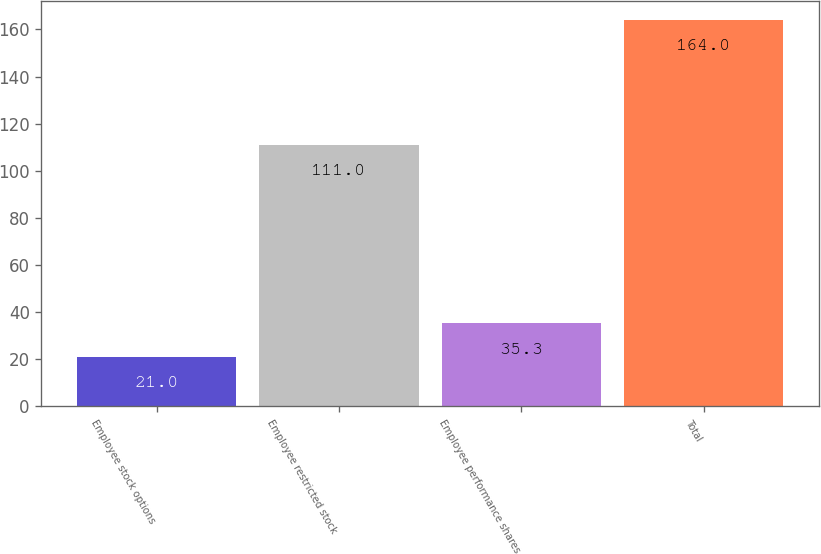<chart> <loc_0><loc_0><loc_500><loc_500><bar_chart><fcel>Employee stock options<fcel>Employee restricted stock<fcel>Employee performance shares<fcel>Total<nl><fcel>21<fcel>111<fcel>35.3<fcel>164<nl></chart> 